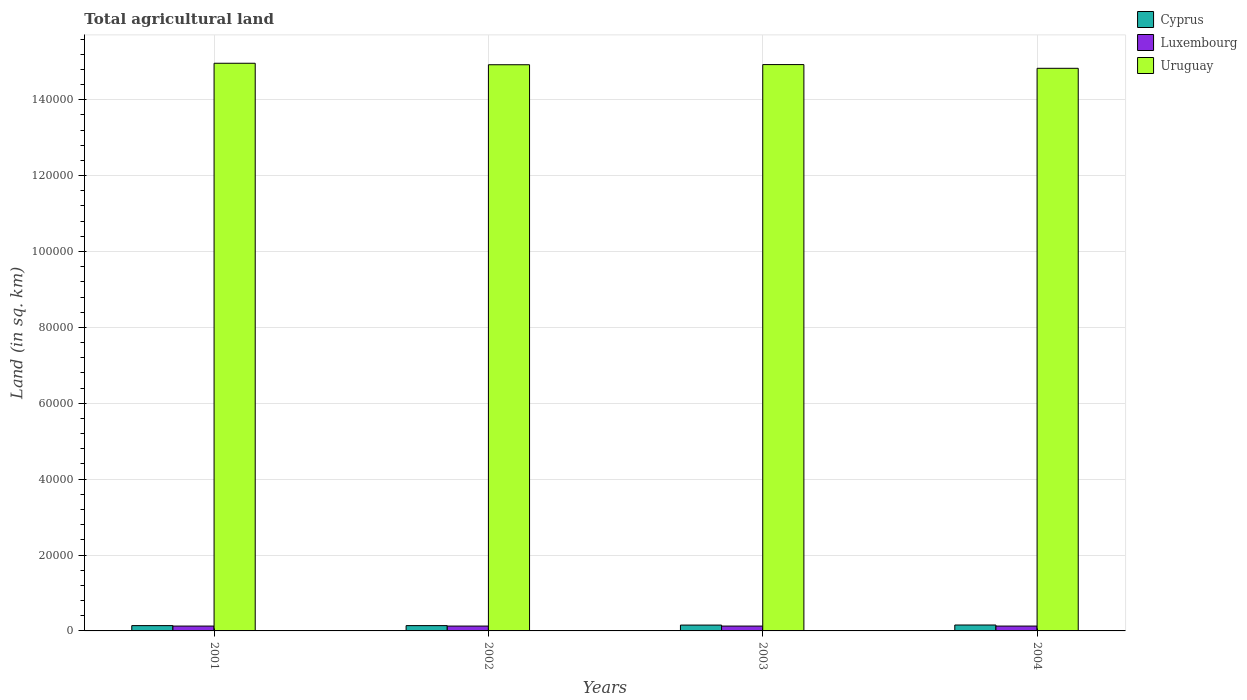How many different coloured bars are there?
Give a very brief answer. 3. Are the number of bars on each tick of the X-axis equal?
Your answer should be compact. Yes. What is the label of the 2nd group of bars from the left?
Ensure brevity in your answer.  2002. What is the total agricultural land in Cyprus in 2001?
Provide a short and direct response. 1400. Across all years, what is the maximum total agricultural land in Uruguay?
Provide a succinct answer. 1.50e+05. Across all years, what is the minimum total agricultural land in Uruguay?
Your response must be concise. 1.48e+05. In which year was the total agricultural land in Luxembourg minimum?
Make the answer very short. 2001. What is the total total agricultural land in Luxembourg in the graph?
Ensure brevity in your answer.  5120. What is the difference between the total agricultural land in Uruguay in 2001 and that in 2004?
Make the answer very short. 1330. What is the difference between the total agricultural land in Luxembourg in 2003 and the total agricultural land in Cyprus in 2002?
Ensure brevity in your answer.  -120. What is the average total agricultural land in Uruguay per year?
Give a very brief answer. 1.49e+05. In the year 2002, what is the difference between the total agricultural land in Luxembourg and total agricultural land in Cyprus?
Your response must be concise. -120. In how many years, is the total agricultural land in Luxembourg greater than 96000 sq.km?
Make the answer very short. 0. Is the difference between the total agricultural land in Luxembourg in 2001 and 2002 greater than the difference between the total agricultural land in Cyprus in 2001 and 2002?
Give a very brief answer. No. What is the difference between the highest and the second highest total agricultural land in Uruguay?
Your answer should be compact. 350. What is the difference between the highest and the lowest total agricultural land in Uruguay?
Give a very brief answer. 1330. In how many years, is the total agricultural land in Uruguay greater than the average total agricultural land in Uruguay taken over all years?
Your answer should be very brief. 3. Is the sum of the total agricultural land in Cyprus in 2001 and 2002 greater than the maximum total agricultural land in Uruguay across all years?
Ensure brevity in your answer.  No. What does the 3rd bar from the left in 2003 represents?
Offer a terse response. Uruguay. What does the 3rd bar from the right in 2004 represents?
Your answer should be compact. Cyprus. Is it the case that in every year, the sum of the total agricultural land in Uruguay and total agricultural land in Luxembourg is greater than the total agricultural land in Cyprus?
Offer a terse response. Yes. Are all the bars in the graph horizontal?
Provide a short and direct response. No. How many years are there in the graph?
Make the answer very short. 4. What is the difference between two consecutive major ticks on the Y-axis?
Your answer should be very brief. 2.00e+04. Are the values on the major ticks of Y-axis written in scientific E-notation?
Provide a succinct answer. No. Where does the legend appear in the graph?
Your answer should be very brief. Top right. What is the title of the graph?
Your response must be concise. Total agricultural land. Does "Korea (Democratic)" appear as one of the legend labels in the graph?
Ensure brevity in your answer.  No. What is the label or title of the Y-axis?
Offer a very short reply. Land (in sq. km). What is the Land (in sq. km) of Cyprus in 2001?
Keep it short and to the point. 1400. What is the Land (in sq. km) in Luxembourg in 2001?
Your answer should be very brief. 1280. What is the Land (in sq. km) of Uruguay in 2001?
Provide a succinct answer. 1.50e+05. What is the Land (in sq. km) in Cyprus in 2002?
Offer a terse response. 1400. What is the Land (in sq. km) of Luxembourg in 2002?
Your answer should be very brief. 1280. What is the Land (in sq. km) of Uruguay in 2002?
Make the answer very short. 1.49e+05. What is the Land (in sq. km) in Cyprus in 2003?
Keep it short and to the point. 1540. What is the Land (in sq. km) of Luxembourg in 2003?
Give a very brief answer. 1280. What is the Land (in sq. km) of Uruguay in 2003?
Offer a very short reply. 1.49e+05. What is the Land (in sq. km) of Cyprus in 2004?
Ensure brevity in your answer.  1560. What is the Land (in sq. km) in Luxembourg in 2004?
Make the answer very short. 1280. What is the Land (in sq. km) of Uruguay in 2004?
Provide a short and direct response. 1.48e+05. Across all years, what is the maximum Land (in sq. km) of Cyprus?
Your answer should be very brief. 1560. Across all years, what is the maximum Land (in sq. km) of Luxembourg?
Provide a short and direct response. 1280. Across all years, what is the maximum Land (in sq. km) of Uruguay?
Your answer should be very brief. 1.50e+05. Across all years, what is the minimum Land (in sq. km) of Cyprus?
Your answer should be very brief. 1400. Across all years, what is the minimum Land (in sq. km) of Luxembourg?
Your answer should be very brief. 1280. Across all years, what is the minimum Land (in sq. km) of Uruguay?
Your answer should be compact. 1.48e+05. What is the total Land (in sq. km) in Cyprus in the graph?
Provide a short and direct response. 5900. What is the total Land (in sq. km) of Luxembourg in the graph?
Offer a terse response. 5120. What is the total Land (in sq. km) of Uruguay in the graph?
Make the answer very short. 5.96e+05. What is the difference between the Land (in sq. km) in Cyprus in 2001 and that in 2002?
Ensure brevity in your answer.  0. What is the difference between the Land (in sq. km) in Uruguay in 2001 and that in 2002?
Ensure brevity in your answer.  390. What is the difference between the Land (in sq. km) in Cyprus in 2001 and that in 2003?
Make the answer very short. -140. What is the difference between the Land (in sq. km) of Luxembourg in 2001 and that in 2003?
Your response must be concise. 0. What is the difference between the Land (in sq. km) of Uruguay in 2001 and that in 2003?
Provide a succinct answer. 350. What is the difference between the Land (in sq. km) of Cyprus in 2001 and that in 2004?
Offer a terse response. -160. What is the difference between the Land (in sq. km) of Luxembourg in 2001 and that in 2004?
Offer a terse response. 0. What is the difference between the Land (in sq. km) in Uruguay in 2001 and that in 2004?
Keep it short and to the point. 1330. What is the difference between the Land (in sq. km) of Cyprus in 2002 and that in 2003?
Give a very brief answer. -140. What is the difference between the Land (in sq. km) of Cyprus in 2002 and that in 2004?
Offer a terse response. -160. What is the difference between the Land (in sq. km) in Luxembourg in 2002 and that in 2004?
Your response must be concise. 0. What is the difference between the Land (in sq. km) in Uruguay in 2002 and that in 2004?
Your response must be concise. 940. What is the difference between the Land (in sq. km) in Luxembourg in 2003 and that in 2004?
Keep it short and to the point. 0. What is the difference between the Land (in sq. km) of Uruguay in 2003 and that in 2004?
Your answer should be very brief. 980. What is the difference between the Land (in sq. km) of Cyprus in 2001 and the Land (in sq. km) of Luxembourg in 2002?
Your answer should be compact. 120. What is the difference between the Land (in sq. km) of Cyprus in 2001 and the Land (in sq. km) of Uruguay in 2002?
Ensure brevity in your answer.  -1.48e+05. What is the difference between the Land (in sq. km) in Luxembourg in 2001 and the Land (in sq. km) in Uruguay in 2002?
Your answer should be compact. -1.48e+05. What is the difference between the Land (in sq. km) of Cyprus in 2001 and the Land (in sq. km) of Luxembourg in 2003?
Offer a very short reply. 120. What is the difference between the Land (in sq. km) of Cyprus in 2001 and the Land (in sq. km) of Uruguay in 2003?
Provide a succinct answer. -1.48e+05. What is the difference between the Land (in sq. km) in Luxembourg in 2001 and the Land (in sq. km) in Uruguay in 2003?
Give a very brief answer. -1.48e+05. What is the difference between the Land (in sq. km) in Cyprus in 2001 and the Land (in sq. km) in Luxembourg in 2004?
Give a very brief answer. 120. What is the difference between the Land (in sq. km) of Cyprus in 2001 and the Land (in sq. km) of Uruguay in 2004?
Keep it short and to the point. -1.47e+05. What is the difference between the Land (in sq. km) of Luxembourg in 2001 and the Land (in sq. km) of Uruguay in 2004?
Your answer should be compact. -1.47e+05. What is the difference between the Land (in sq. km) of Cyprus in 2002 and the Land (in sq. km) of Luxembourg in 2003?
Give a very brief answer. 120. What is the difference between the Land (in sq. km) of Cyprus in 2002 and the Land (in sq. km) of Uruguay in 2003?
Give a very brief answer. -1.48e+05. What is the difference between the Land (in sq. km) of Luxembourg in 2002 and the Land (in sq. km) of Uruguay in 2003?
Give a very brief answer. -1.48e+05. What is the difference between the Land (in sq. km) of Cyprus in 2002 and the Land (in sq. km) of Luxembourg in 2004?
Your response must be concise. 120. What is the difference between the Land (in sq. km) of Cyprus in 2002 and the Land (in sq. km) of Uruguay in 2004?
Ensure brevity in your answer.  -1.47e+05. What is the difference between the Land (in sq. km) of Luxembourg in 2002 and the Land (in sq. km) of Uruguay in 2004?
Provide a succinct answer. -1.47e+05. What is the difference between the Land (in sq. km) of Cyprus in 2003 and the Land (in sq. km) of Luxembourg in 2004?
Keep it short and to the point. 260. What is the difference between the Land (in sq. km) in Cyprus in 2003 and the Land (in sq. km) in Uruguay in 2004?
Keep it short and to the point. -1.47e+05. What is the difference between the Land (in sq. km) in Luxembourg in 2003 and the Land (in sq. km) in Uruguay in 2004?
Offer a very short reply. -1.47e+05. What is the average Land (in sq. km) of Cyprus per year?
Your answer should be very brief. 1475. What is the average Land (in sq. km) in Luxembourg per year?
Your answer should be compact. 1280. What is the average Land (in sq. km) in Uruguay per year?
Ensure brevity in your answer.  1.49e+05. In the year 2001, what is the difference between the Land (in sq. km) of Cyprus and Land (in sq. km) of Luxembourg?
Provide a short and direct response. 120. In the year 2001, what is the difference between the Land (in sq. km) of Cyprus and Land (in sq. km) of Uruguay?
Provide a succinct answer. -1.48e+05. In the year 2001, what is the difference between the Land (in sq. km) of Luxembourg and Land (in sq. km) of Uruguay?
Your answer should be very brief. -1.48e+05. In the year 2002, what is the difference between the Land (in sq. km) of Cyprus and Land (in sq. km) of Luxembourg?
Keep it short and to the point. 120. In the year 2002, what is the difference between the Land (in sq. km) of Cyprus and Land (in sq. km) of Uruguay?
Provide a succinct answer. -1.48e+05. In the year 2002, what is the difference between the Land (in sq. km) in Luxembourg and Land (in sq. km) in Uruguay?
Provide a succinct answer. -1.48e+05. In the year 2003, what is the difference between the Land (in sq. km) of Cyprus and Land (in sq. km) of Luxembourg?
Ensure brevity in your answer.  260. In the year 2003, what is the difference between the Land (in sq. km) in Cyprus and Land (in sq. km) in Uruguay?
Your response must be concise. -1.48e+05. In the year 2003, what is the difference between the Land (in sq. km) in Luxembourg and Land (in sq. km) in Uruguay?
Your answer should be compact. -1.48e+05. In the year 2004, what is the difference between the Land (in sq. km) of Cyprus and Land (in sq. km) of Luxembourg?
Your answer should be compact. 280. In the year 2004, what is the difference between the Land (in sq. km) in Cyprus and Land (in sq. km) in Uruguay?
Keep it short and to the point. -1.47e+05. In the year 2004, what is the difference between the Land (in sq. km) of Luxembourg and Land (in sq. km) of Uruguay?
Your response must be concise. -1.47e+05. What is the ratio of the Land (in sq. km) in Luxembourg in 2001 to that in 2002?
Provide a succinct answer. 1. What is the ratio of the Land (in sq. km) in Luxembourg in 2001 to that in 2003?
Give a very brief answer. 1. What is the ratio of the Land (in sq. km) in Uruguay in 2001 to that in 2003?
Your answer should be very brief. 1. What is the ratio of the Land (in sq. km) in Cyprus in 2001 to that in 2004?
Offer a very short reply. 0.9. What is the ratio of the Land (in sq. km) in Uruguay in 2001 to that in 2004?
Offer a terse response. 1.01. What is the ratio of the Land (in sq. km) of Uruguay in 2002 to that in 2003?
Your response must be concise. 1. What is the ratio of the Land (in sq. km) of Cyprus in 2002 to that in 2004?
Your answer should be very brief. 0.9. What is the ratio of the Land (in sq. km) in Luxembourg in 2002 to that in 2004?
Your answer should be compact. 1. What is the ratio of the Land (in sq. km) of Uruguay in 2002 to that in 2004?
Give a very brief answer. 1.01. What is the ratio of the Land (in sq. km) of Cyprus in 2003 to that in 2004?
Provide a short and direct response. 0.99. What is the ratio of the Land (in sq. km) of Luxembourg in 2003 to that in 2004?
Your answer should be compact. 1. What is the ratio of the Land (in sq. km) in Uruguay in 2003 to that in 2004?
Your response must be concise. 1.01. What is the difference between the highest and the second highest Land (in sq. km) in Luxembourg?
Provide a succinct answer. 0. What is the difference between the highest and the second highest Land (in sq. km) in Uruguay?
Provide a succinct answer. 350. What is the difference between the highest and the lowest Land (in sq. km) in Cyprus?
Offer a very short reply. 160. What is the difference between the highest and the lowest Land (in sq. km) in Uruguay?
Keep it short and to the point. 1330. 